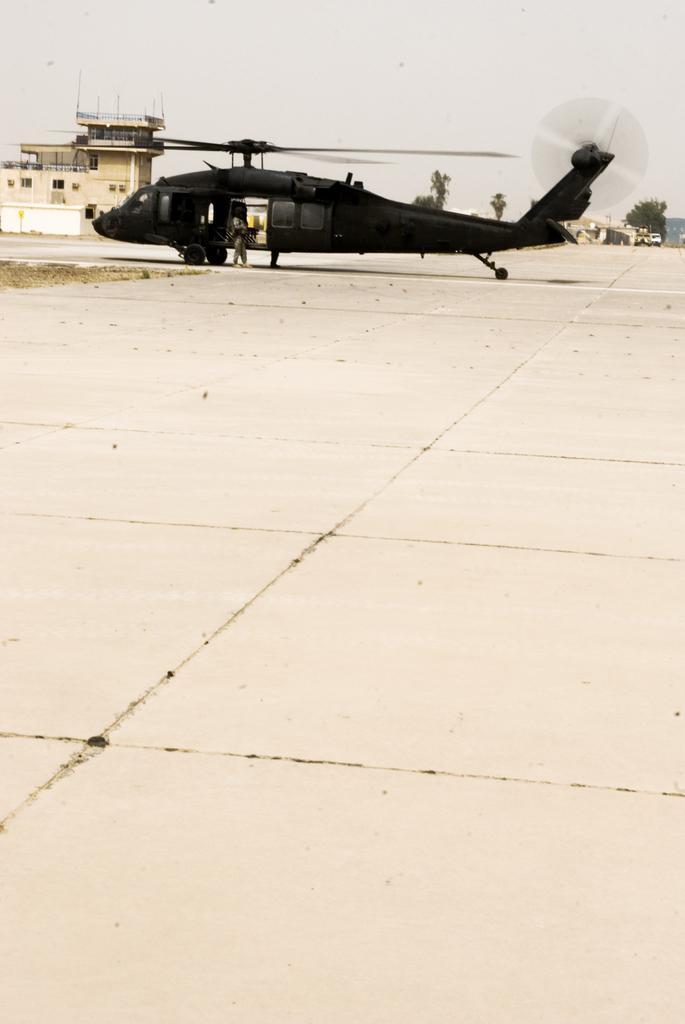Please provide a concise description of this image. In this image there is a ground in that ground there is helicopter, in the background there is a building, trees and a sky. 